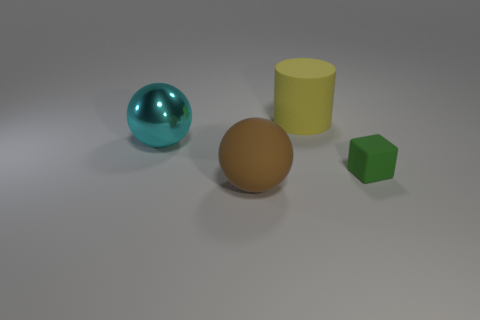Add 2 big yellow matte blocks. How many objects exist? 6 Subtract all cubes. How many objects are left? 3 Add 2 big rubber cylinders. How many big rubber cylinders are left? 3 Add 4 rubber objects. How many rubber objects exist? 7 Subtract 1 green blocks. How many objects are left? 3 Subtract all cyan matte things. Subtract all rubber blocks. How many objects are left? 3 